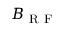Convert formula to latex. <formula><loc_0><loc_0><loc_500><loc_500>B _ { R F }</formula> 